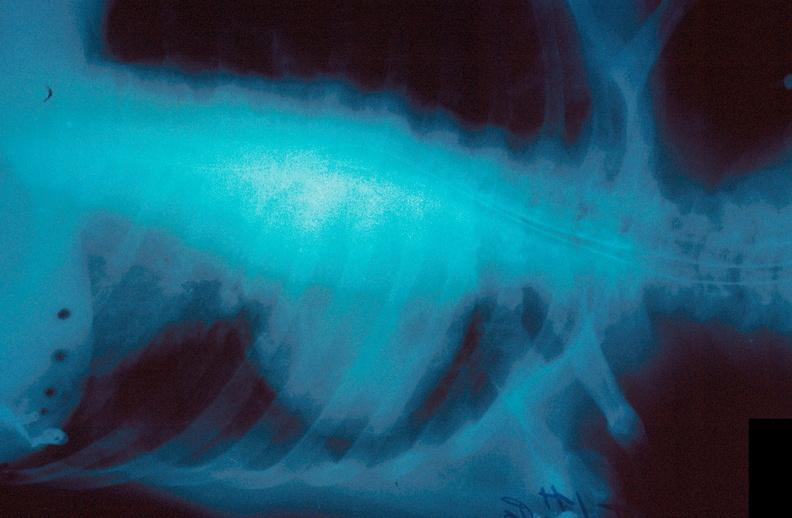what is present?
Answer the question using a single word or phrase. Respiratory 